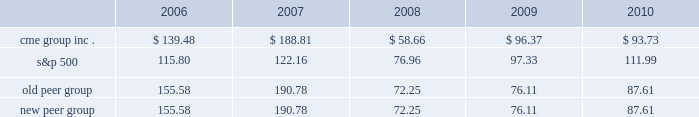Performance graph the following graph compares the cumulative five-year total return provided shareholders on our class a common stock relative to the cumulative total returns of the s&p 500 index and two customized peer groups .
The old peer group includes intercontinentalexchange , inc. , nyse euronext and the nasdaq omx group inc .
The new peer group is the same as the old peer group with the addition of cboe holdings , inc .
Which completed its initial public offering in june 2010 .
An investment of $ 100 ( with reinvestment of all dividends ) is assumed to have been made in our class a common stock , in the peer groups and the s&p 500 index on december 31 , 2005 and its relative performance is tracked through december 31 , 2010 .
Comparison of 5 year cumulative total return* among cme group inc. , the s&p 500 index , an old peer group and a new peer group 12/05 12/06 12/07 12/08 12/09 12/10 cme group inc .
S&p 500 old peer group *$ 100 invested on 12/31/05 in stock or index , including reinvestment of dividends .
Fiscal year ending december 31 .
Copyright a9 2011 s&p , a division of the mcgraw-hill companies inc .
All rights reserved .
New peer group the stock price performance included in this graph is not necessarily indicative of future stock price performance .

What was the ratio of the performance as shown for the cme group inc . to the s&p 500 in 2017? 
Computations: (188.81 / 122.16)
Answer: 1.5456. 